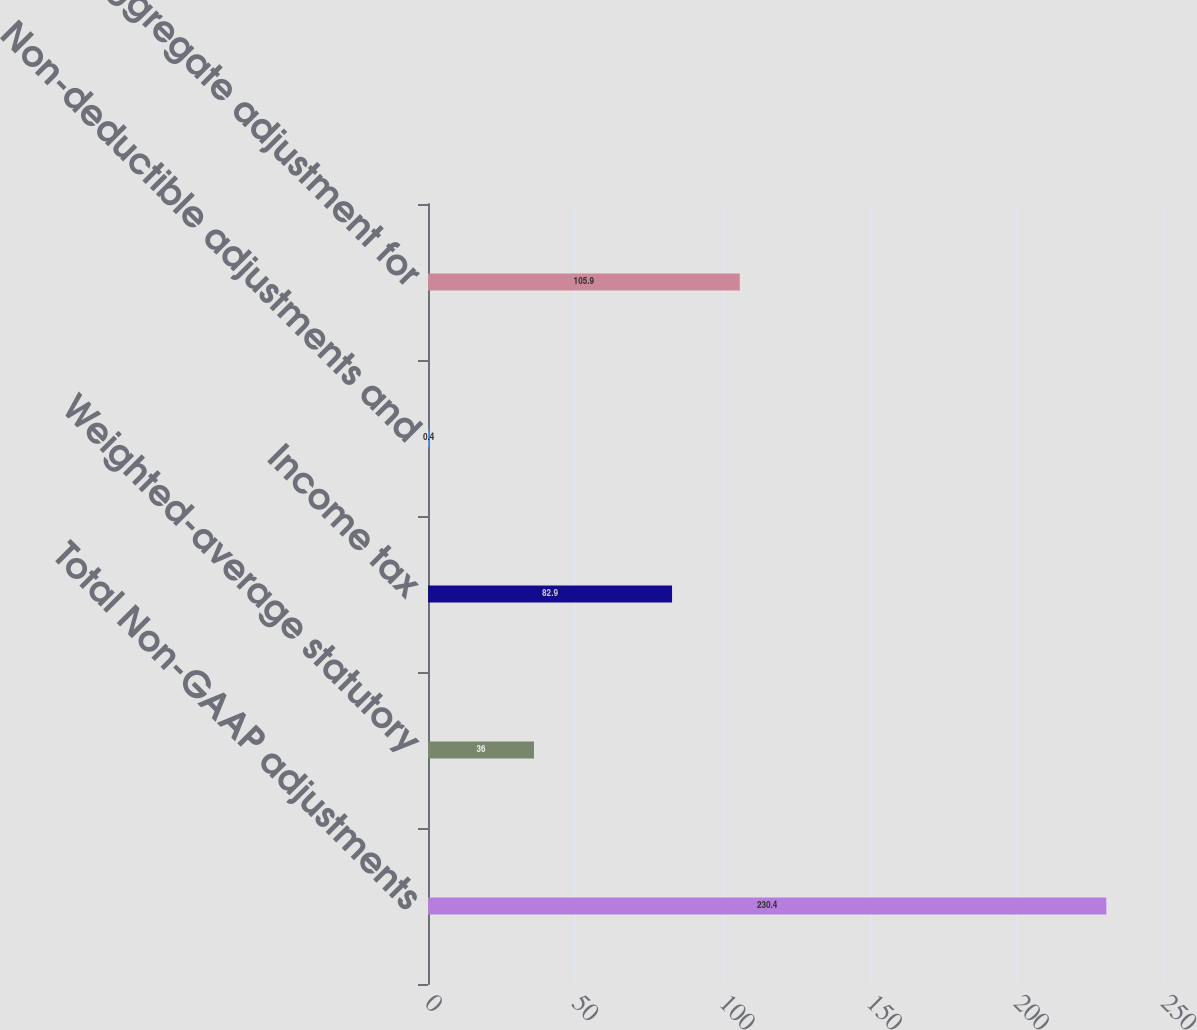Convert chart. <chart><loc_0><loc_0><loc_500><loc_500><bar_chart><fcel>Total Non-GAAP adjustments<fcel>Weighted-average statutory<fcel>Income tax<fcel>Non-deductible adjustments and<fcel>Total aggregate adjustment for<nl><fcel>230.4<fcel>36<fcel>82.9<fcel>0.4<fcel>105.9<nl></chart> 